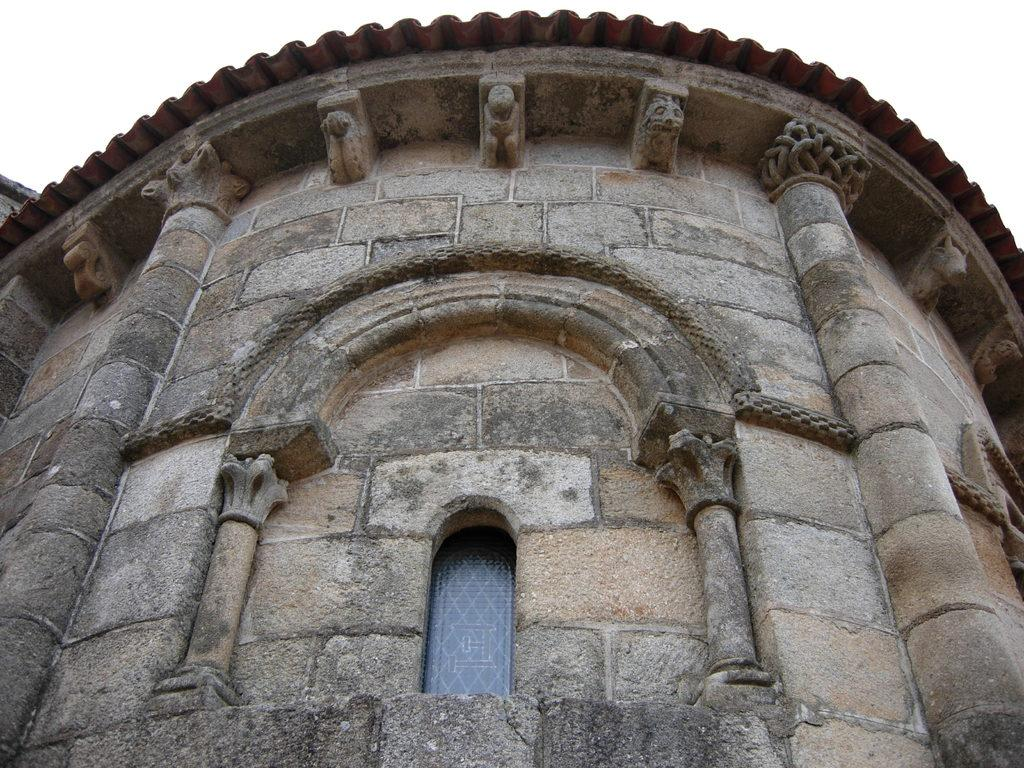What is the main subject in the middle of the image? There is a monument in the middle of the image. What is visible at the top of the image? The sky is visible at the top of the image. Can you tell me how many islands are visible in the image? There are no islands present in the image. What type of badge is being worn by the monument in the image? There is no badge present in the image, as it features a monument and the sky. 